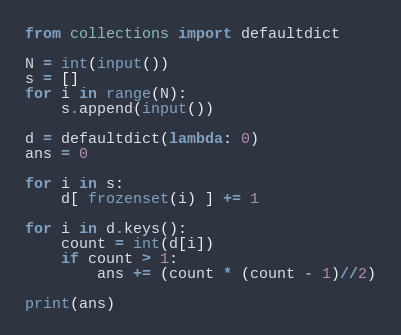<code> <loc_0><loc_0><loc_500><loc_500><_Python_>from collections import defaultdict

N = int(input())
s = []
for i in range(N):
    s.append(input())

d = defaultdict(lambda: 0)
ans = 0

for i in s:
    d[ frozenset(i) ] += 1

for i in d.keys():
    count = int(d[i])
    if count > 1:
        ans += (count * (count - 1)//2)

print(ans)</code> 